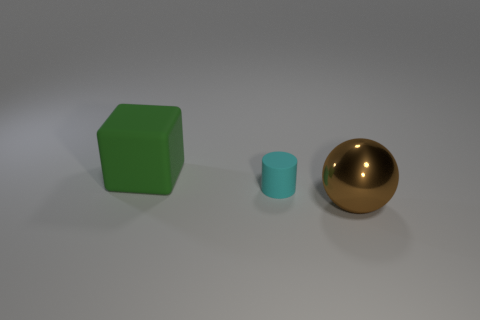Is there any other thing that is made of the same material as the large sphere?
Your answer should be very brief. No. Is there a small cyan thing that has the same material as the large green cube?
Your response must be concise. Yes. Is the green block made of the same material as the big thing on the right side of the cyan matte cylinder?
Provide a short and direct response. No. There is a matte thing right of the large thing that is behind the tiny object; what shape is it?
Make the answer very short. Cylinder. There is a thing in front of the cyan cylinder; does it have the same size as the green object?
Offer a very short reply. Yes. What number of other things are the same shape as the big green matte thing?
Your answer should be compact. 0. Is there a large cube of the same color as the small thing?
Provide a succinct answer. No. How many things are on the left side of the big brown metal object?
Provide a short and direct response. 2. What number of other objects are the same size as the sphere?
Ensure brevity in your answer.  1. Is the large object behind the brown thing made of the same material as the large thing that is right of the small cylinder?
Offer a terse response. No. 